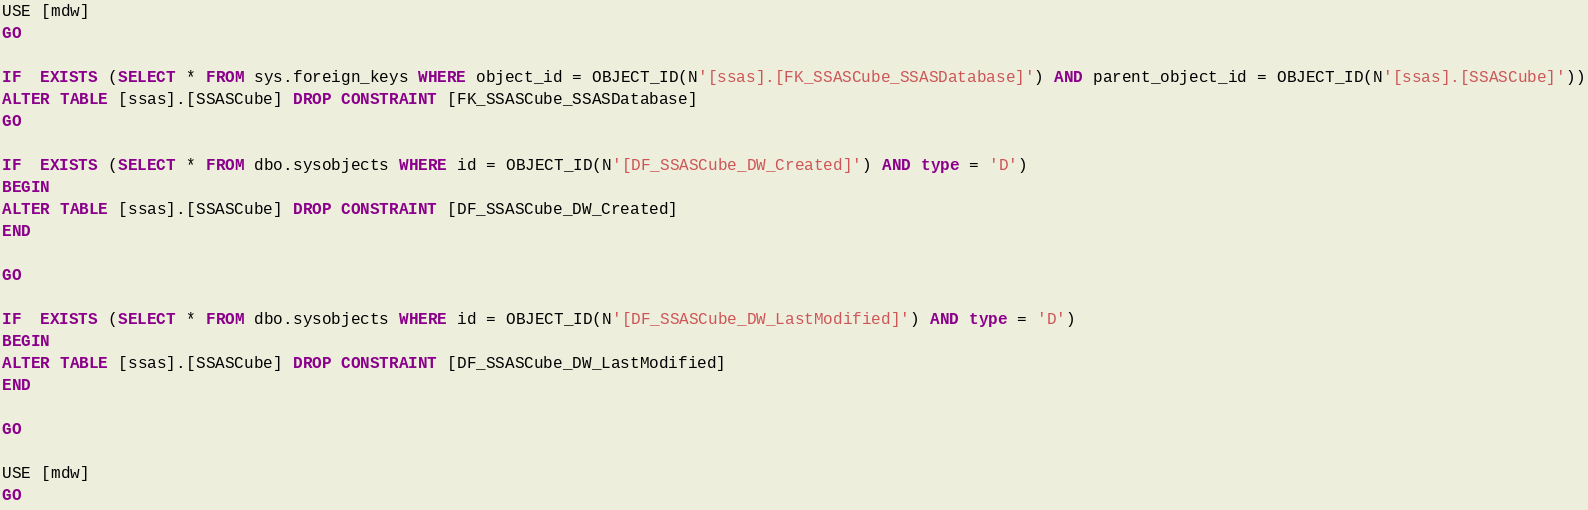Convert code to text. <code><loc_0><loc_0><loc_500><loc_500><_SQL_>USE [mdw]
GO

IF  EXISTS (SELECT * FROM sys.foreign_keys WHERE object_id = OBJECT_ID(N'[ssas].[FK_SSASCube_SSASDatabase]') AND parent_object_id = OBJECT_ID(N'[ssas].[SSASCube]'))
ALTER TABLE [ssas].[SSASCube] DROP CONSTRAINT [FK_SSASCube_SSASDatabase]
GO

IF  EXISTS (SELECT * FROM dbo.sysobjects WHERE id = OBJECT_ID(N'[DF_SSASCube_DW_Created]') AND type = 'D')
BEGIN
ALTER TABLE [ssas].[SSASCube] DROP CONSTRAINT [DF_SSASCube_DW_Created]
END

GO

IF  EXISTS (SELECT * FROM dbo.sysobjects WHERE id = OBJECT_ID(N'[DF_SSASCube_DW_LastModified]') AND type = 'D')
BEGIN
ALTER TABLE [ssas].[SSASCube] DROP CONSTRAINT [DF_SSASCube_DW_LastModified]
END

GO

USE [mdw]
GO
</code> 